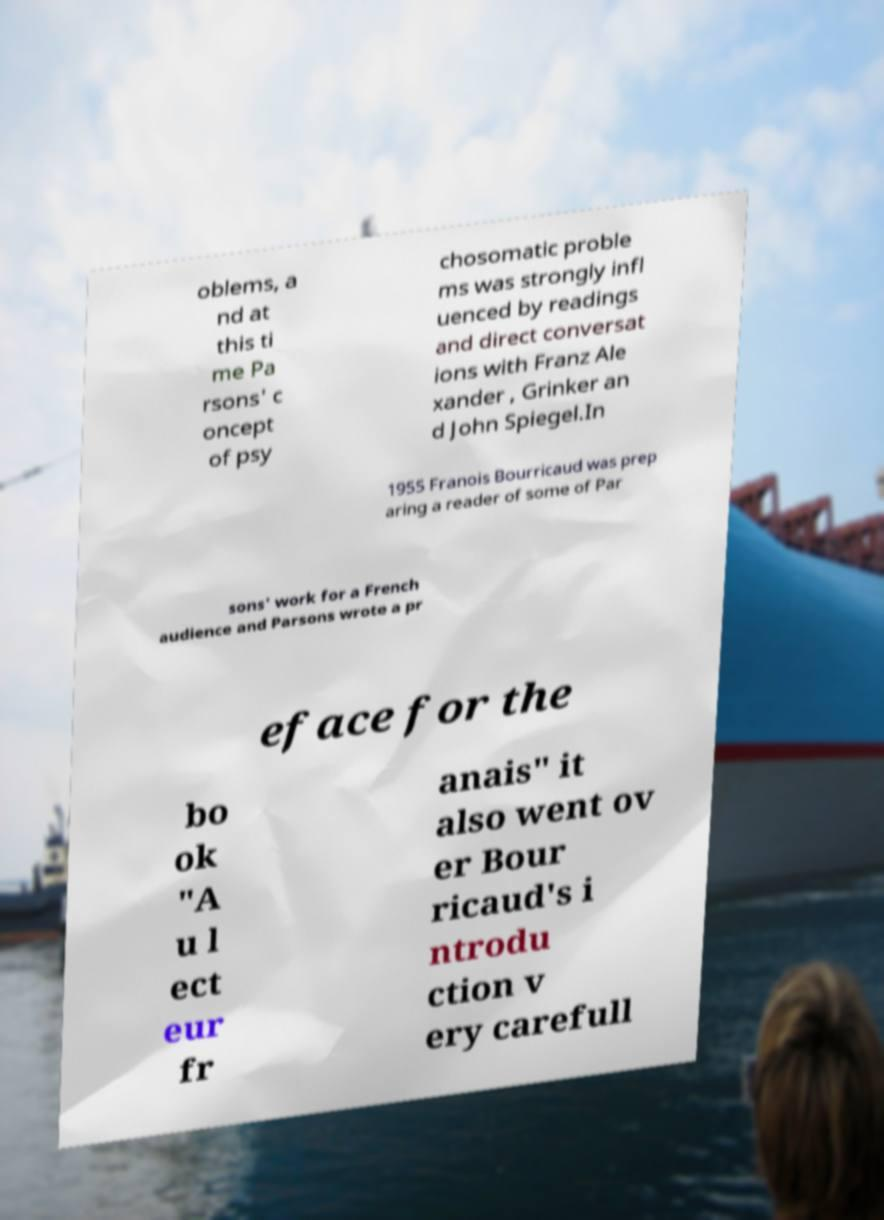Can you read and provide the text displayed in the image?This photo seems to have some interesting text. Can you extract and type it out for me? oblems, a nd at this ti me Pa rsons' c oncept of psy chosomatic proble ms was strongly infl uenced by readings and direct conversat ions with Franz Ale xander , Grinker an d John Spiegel.In 1955 Franois Bourricaud was prep aring a reader of some of Par sons' work for a French audience and Parsons wrote a pr eface for the bo ok "A u l ect eur fr anais" it also went ov er Bour ricaud's i ntrodu ction v ery carefull 